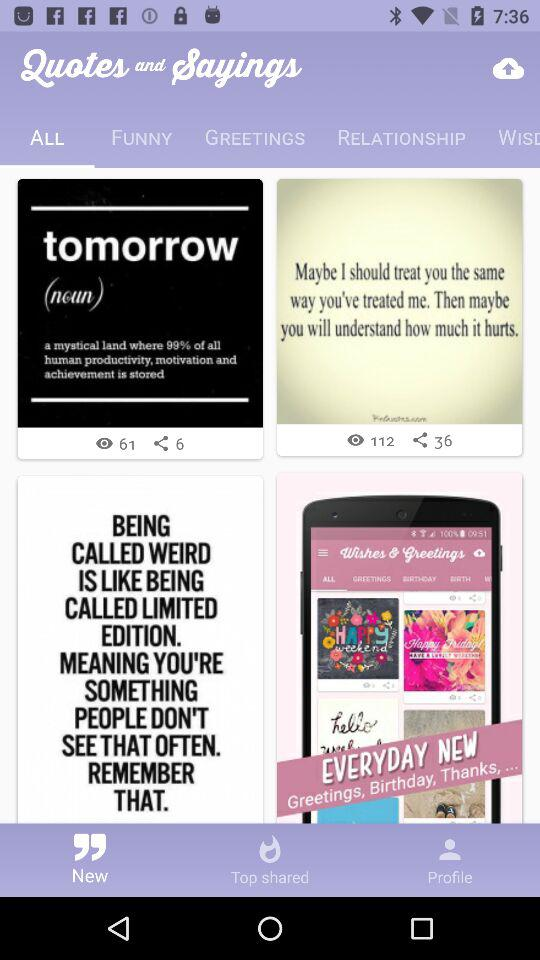Which tab is selected? The selected tab is "ALL". 